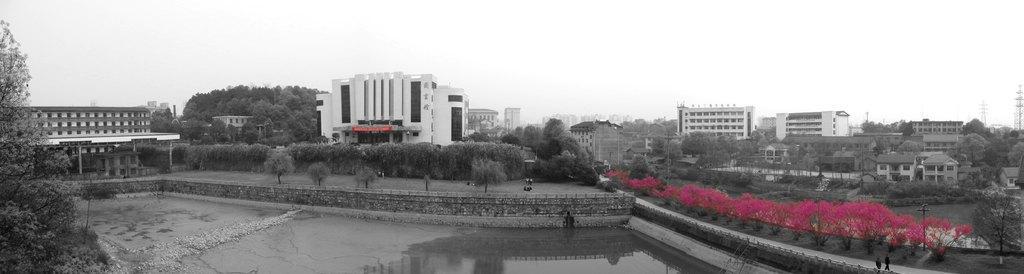Could you give a brief overview of what you see in this image? This image is taken outdoors. At the bottom of the image there is a pond with water and there is a floor. At the top of the image there is a sky. In the middle of the image there are many buildings and houses and there are many trees, plants, poles with street lights and towers. On the left side of the image there is a tree. On the right side of the image there are a few plants and two persons are walking on the road. 